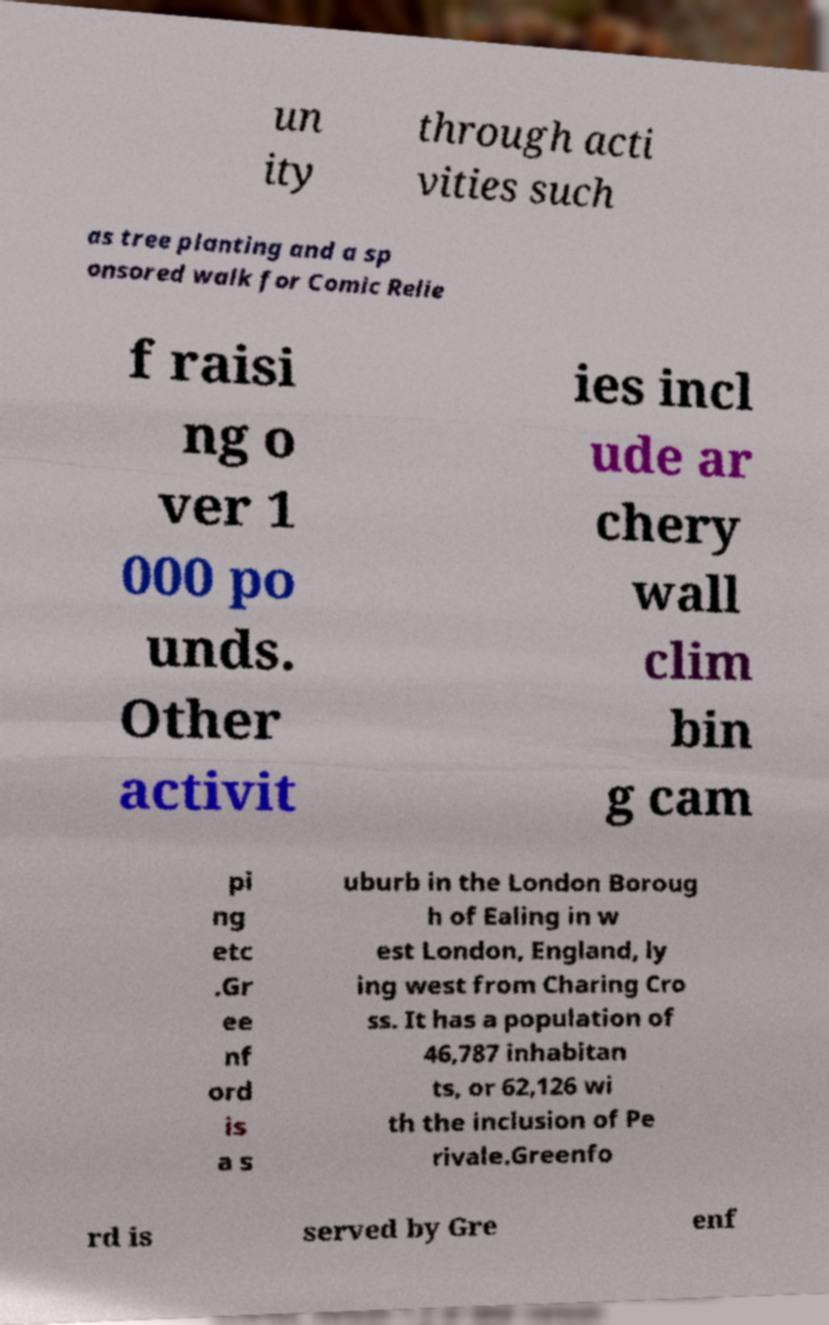Please identify and transcribe the text found in this image. un ity through acti vities such as tree planting and a sp onsored walk for Comic Relie f raisi ng o ver 1 000 po unds. Other activit ies incl ude ar chery wall clim bin g cam pi ng etc .Gr ee nf ord is a s uburb in the London Boroug h of Ealing in w est London, England, ly ing west from Charing Cro ss. It has a population of 46,787 inhabitan ts, or 62,126 wi th the inclusion of Pe rivale.Greenfo rd is served by Gre enf 